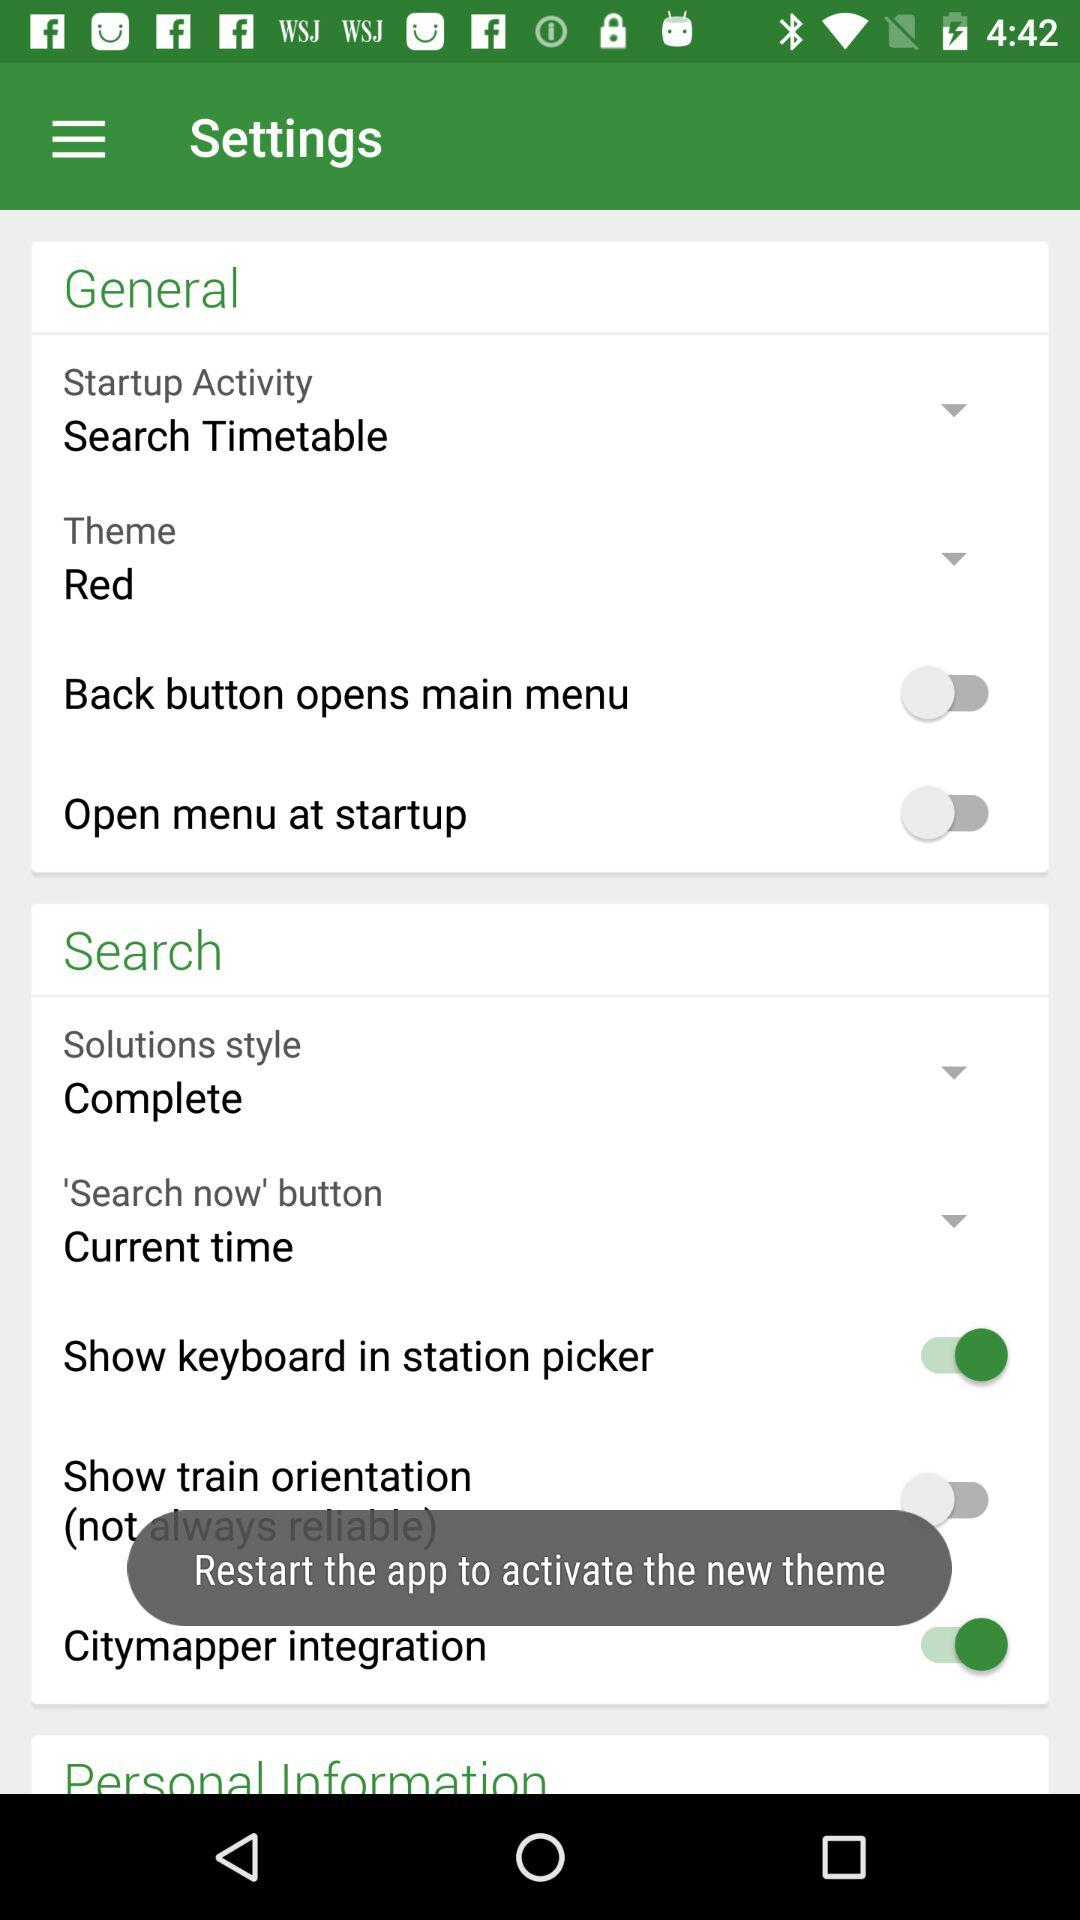What is the theme color? The theme color is red. 